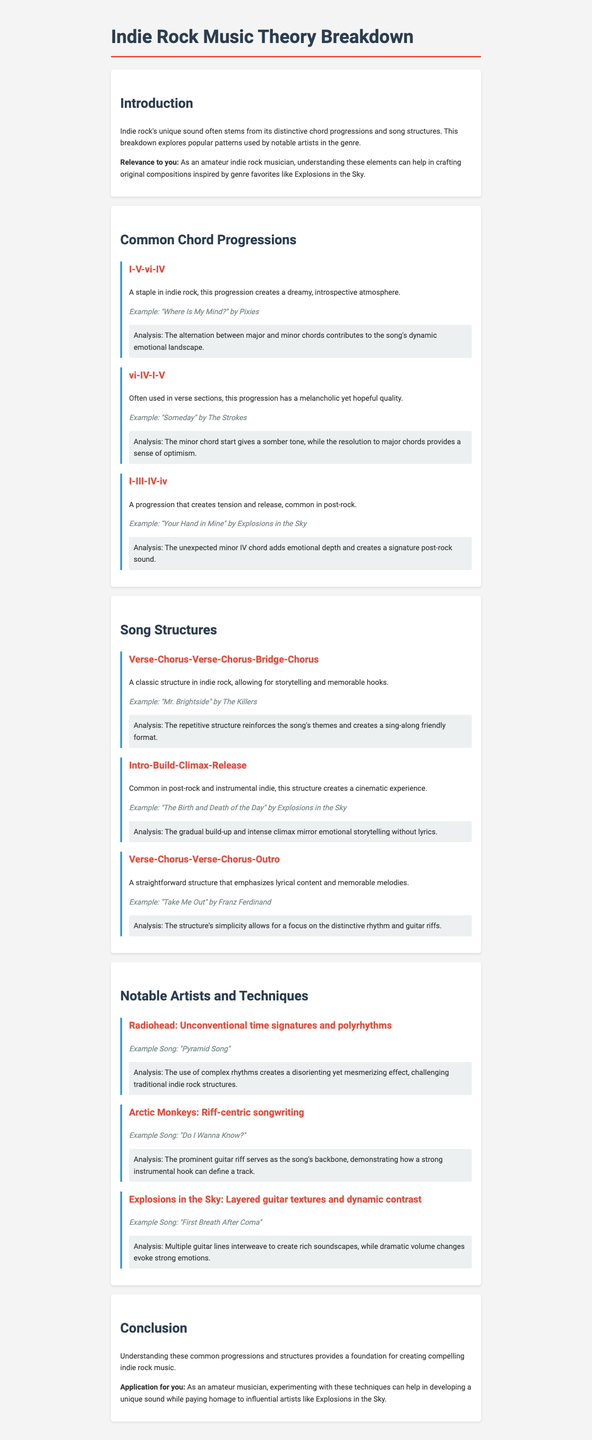what is the example song for the I-V-vi-IV progression? The example song is provided in the section about common chord progressions, specifically for the I-V-vi-IV progression.
Answer: "Where Is My Mind?" by Pixies what does the vi-IV-I-V progression convey? The vi-IV-I-V progression description states it has a melancholic yet hopeful quality, emphasizing its tonal characteristics.
Answer: melancholic yet hopeful who is the artist associated with the technique of layered guitar textures? The document lists notable artists and their techniques; the artist for this technique is identified.
Answer: Explosions in the Sky what structure is commonly used in "Take Me Out"? The song structure is noted under the section about song structures, specifically linked to the song mentioned.
Answer: Verse-Chorus-Verse-Chorus-Outro what is the typical analysis focus for a Verse-Chorus-Verse-Chorus-Bridge-Chorus structure? The analysis provided in the document highlights the repetitive structure and themes reinforced through the song.
Answer: themes and sing-along friendly format what is one common element of the "Intro-Build-Climax-Release" structure? This structure is discussed in the context of creating a cinematic experience, reflecting its primary focus.
Answer: cinematic experience which artist is known for unconventional time signatures? The section highlights notable artists and their unique techniques, identifying the relevant artist for this technique.
Answer: Radiohead how many common chord progressions are listed in the document? The number is found by counting the progressions provided in the respective section of the document.
Answer: three 